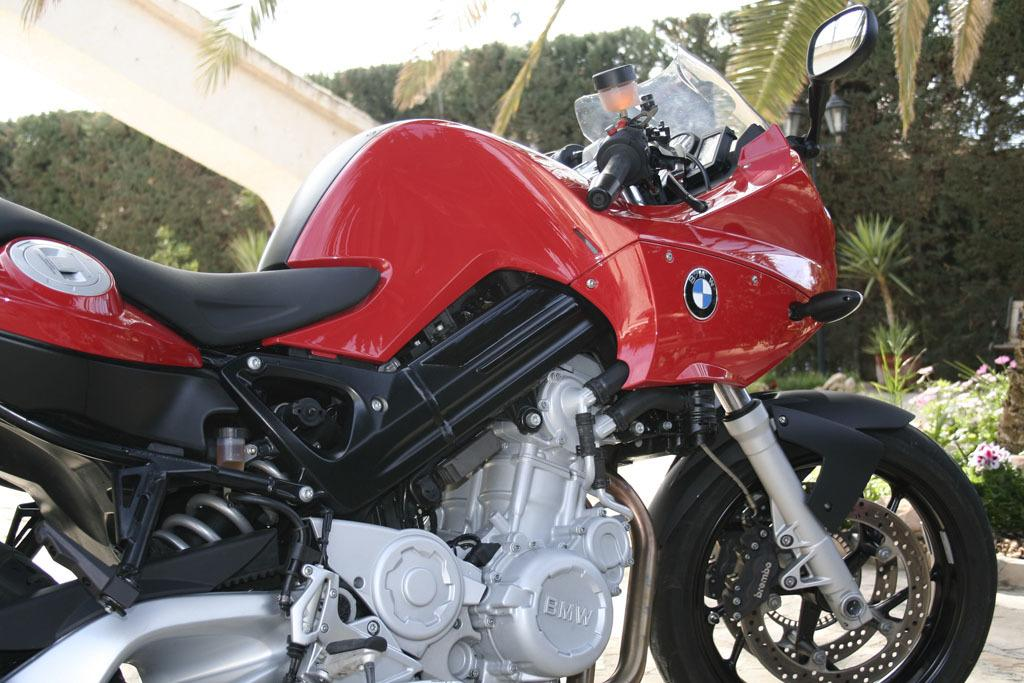What type of vehicle is in the image? There is a red sports bike in the image. What can be seen in the background of the image? There are coconut trees visible in the background. What type of plants are in the image? There are plants in pots in the image. What is the texture of the interest rate on the sports bike? There is no mention of an interest rate in the image, and the sports bike does not have a texture related to interest rates. 